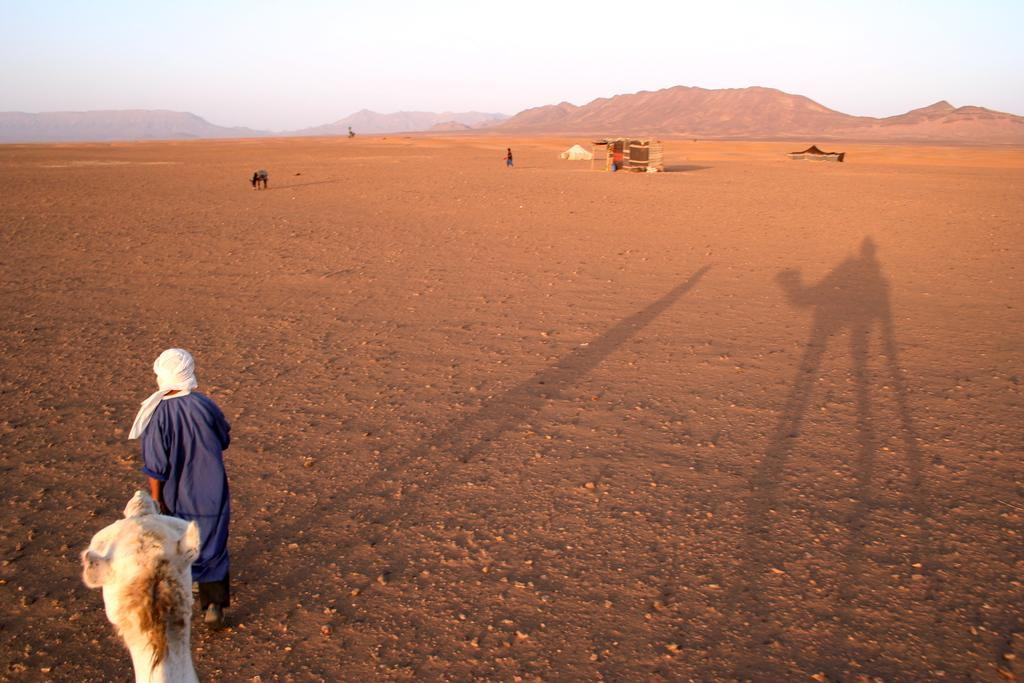What is the person on the right side of the image doing? The person is walking on the right side of the image. What is located behind the person? There is an animal behind the person. What can be seen in the background of the image? The background of the image includes the sky, a hill, and a hut. How many additional animals can be seen in the background of the image? There is at least one additional animal in the background of the image. How many additional people can be seen in the background of the image? There is at least one additional person in the background of the image. What type of soda is being served in the hut in the image? There is no soda present in the image; the hut is in the background and does not show any food or drink items. 